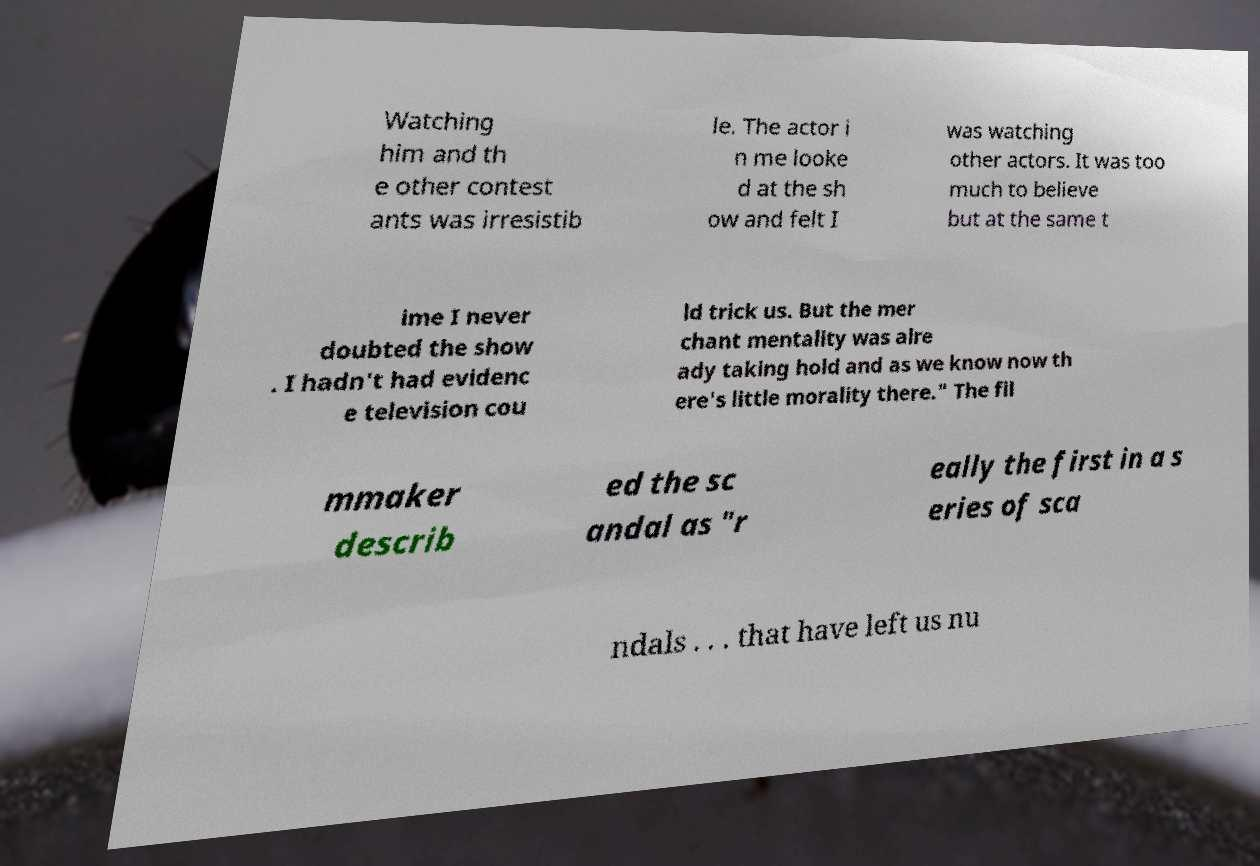Can you accurately transcribe the text from the provided image for me? Watching him and th e other contest ants was irresistib le. The actor i n me looke d at the sh ow and felt I was watching other actors. It was too much to believe but at the same t ime I never doubted the show . I hadn't had evidenc e television cou ld trick us. But the mer chant mentality was alre ady taking hold and as we know now th ere's little morality there." The fil mmaker describ ed the sc andal as "r eally the first in a s eries of sca ndals . . . that have left us nu 